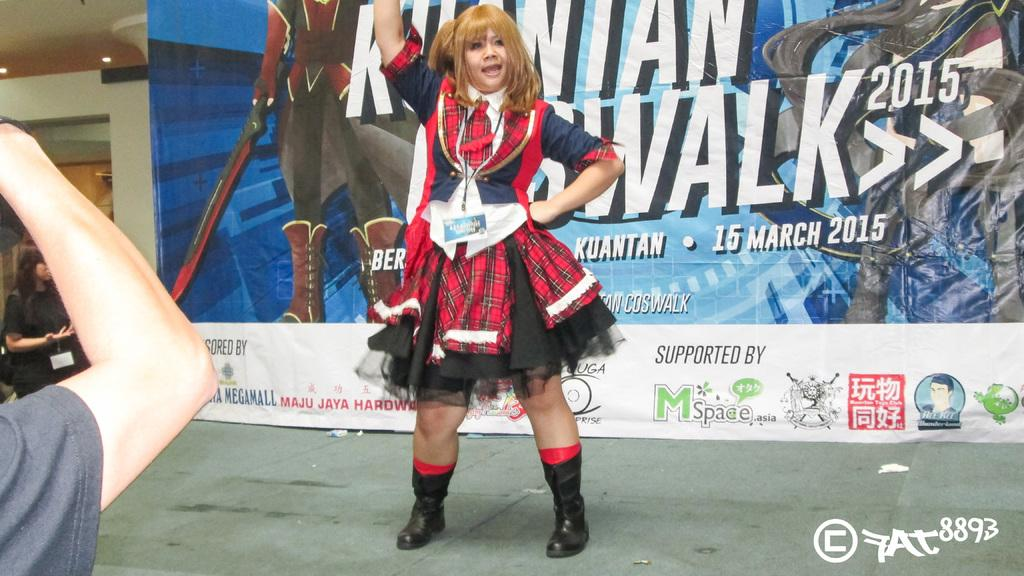<image>
Render a clear and concise summary of the photo. woman in plaid costume in front of sign for kauntan walk 2015 